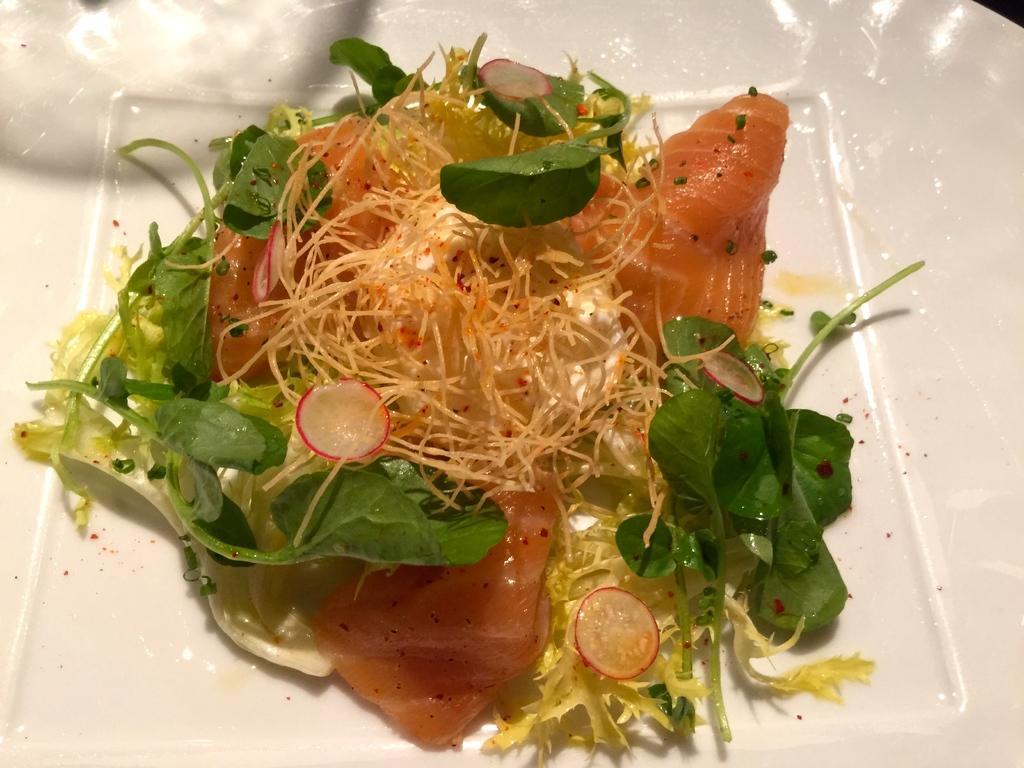Could you give a brief overview of what you see in this image? In this image I see a white plate and on the plate I see food and I can also see few green color leaves. 